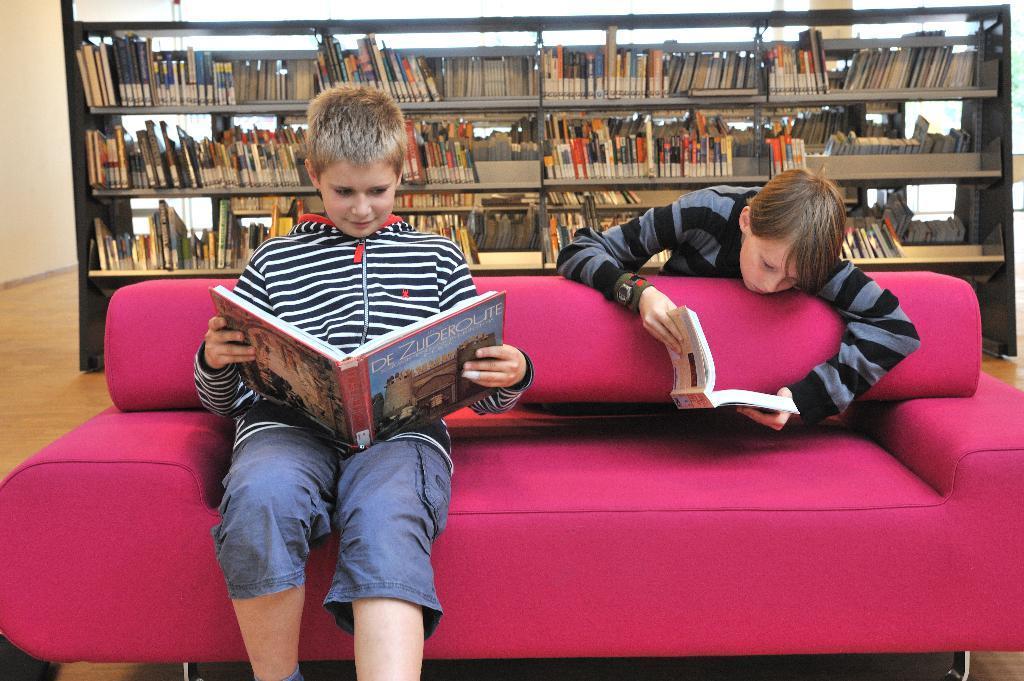Can you describe this image briefly? Here there was a couch and here there are two persons one of the person the left side person he is reading book,as well the right person he is also reading book but he is standing back of the couch. And around them there are several objects. Coming to the background here there was big shelf with full of books. 